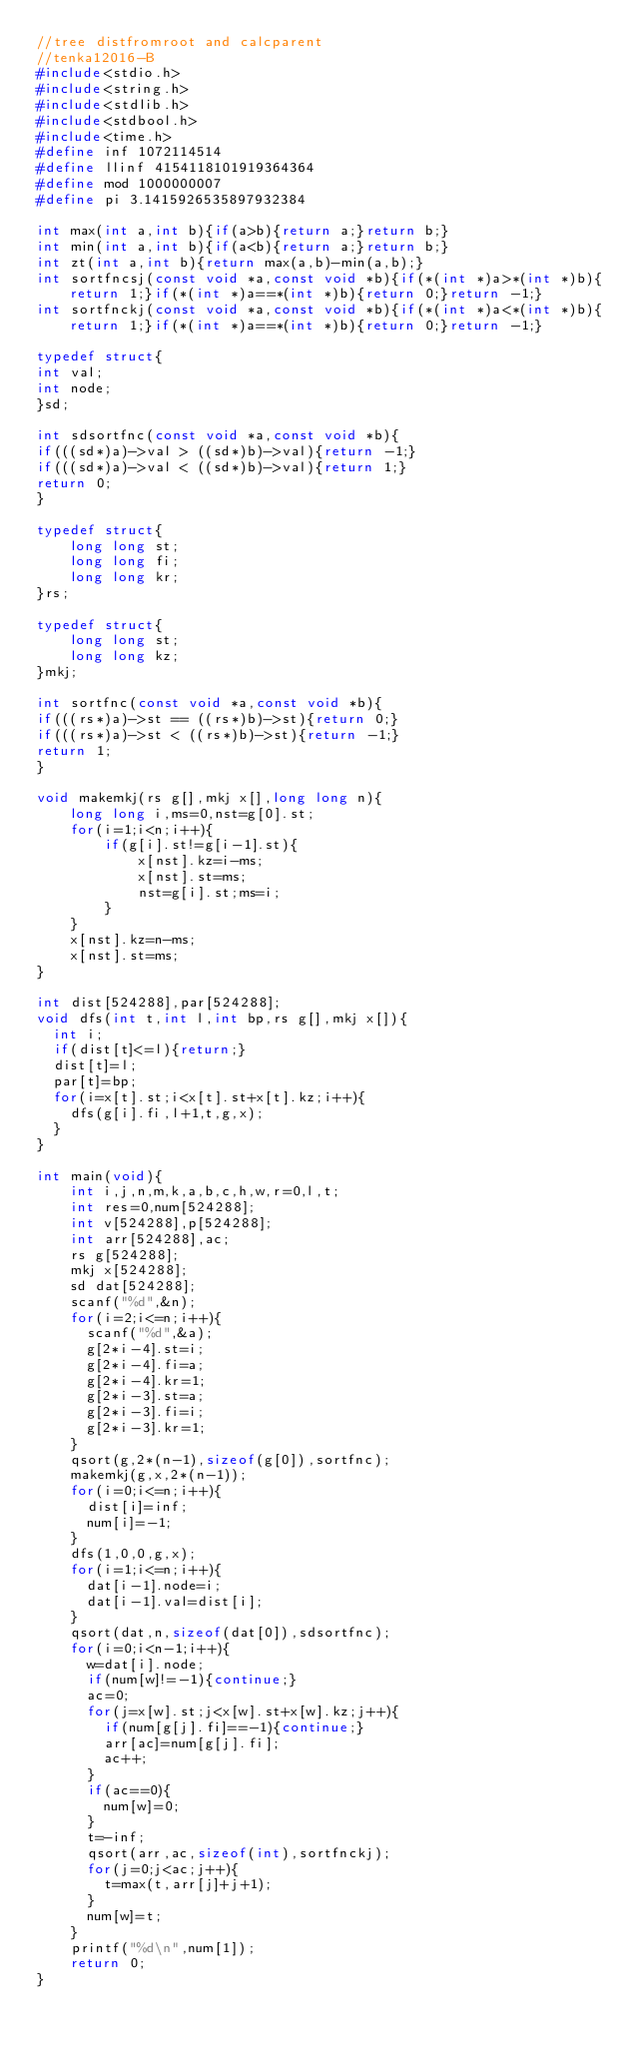<code> <loc_0><loc_0><loc_500><loc_500><_C_>//tree distfromroot and calcparent
//tenka12016-B
#include<stdio.h>
#include<string.h>
#include<stdlib.h>
#include<stdbool.h>
#include<time.h>
#define inf 1072114514
#define llinf 4154118101919364364
#define mod 1000000007
#define pi 3.1415926535897932384

int max(int a,int b){if(a>b){return a;}return b;}
int min(int a,int b){if(a<b){return a;}return b;}
int zt(int a,int b){return max(a,b)-min(a,b);}
int sortfncsj(const void *a,const void *b){if(*(int *)a>*(int *)b){return 1;}if(*(int *)a==*(int *)b){return 0;}return -1;}
int sortfnckj(const void *a,const void *b){if(*(int *)a<*(int *)b){return 1;}if(*(int *)a==*(int *)b){return 0;}return -1;}

typedef struct{
int val;
int node;
}sd;

int sdsortfnc(const void *a,const void *b){
if(((sd*)a)->val > ((sd*)b)->val){return -1;}
if(((sd*)a)->val < ((sd*)b)->val){return 1;}
return 0;
}

typedef struct{
    long long st;
    long long fi;
    long long kr;
}rs;

typedef struct{
    long long st;
    long long kz;
}mkj;

int sortfnc(const void *a,const void *b){
if(((rs*)a)->st == ((rs*)b)->st){return 0;}
if(((rs*)a)->st < ((rs*)b)->st){return -1;}
return 1;
}

void makemkj(rs g[],mkj x[],long long n){
    long long i,ms=0,nst=g[0].st;
    for(i=1;i<n;i++){
        if(g[i].st!=g[i-1].st){
            x[nst].kz=i-ms;
            x[nst].st=ms;
            nst=g[i].st;ms=i;
        }
    }
    x[nst].kz=n-ms;
    x[nst].st=ms;
}

int dist[524288],par[524288];
void dfs(int t,int l,int bp,rs g[],mkj x[]){
  int i;
  if(dist[t]<=l){return;}
  dist[t]=l;
  par[t]=bp;
  for(i=x[t].st;i<x[t].st+x[t].kz;i++){
    dfs(g[i].fi,l+1,t,g,x);
  }
}

int main(void){
    int i,j,n,m,k,a,b,c,h,w,r=0,l,t;
    int res=0,num[524288];
    int v[524288],p[524288];
    int arr[524288],ac;
    rs g[524288];
    mkj x[524288];
    sd dat[524288];
    scanf("%d",&n);
    for(i=2;i<=n;i++){
      scanf("%d",&a);
      g[2*i-4].st=i;
      g[2*i-4].fi=a;
      g[2*i-4].kr=1;
      g[2*i-3].st=a;
      g[2*i-3].fi=i;
      g[2*i-3].kr=1;
    }
    qsort(g,2*(n-1),sizeof(g[0]),sortfnc);
    makemkj(g,x,2*(n-1));
    for(i=0;i<=n;i++){
      dist[i]=inf;
      num[i]=-1;
    }
    dfs(1,0,0,g,x);
    for(i=1;i<=n;i++){
      dat[i-1].node=i;
      dat[i-1].val=dist[i];
    }
    qsort(dat,n,sizeof(dat[0]),sdsortfnc);
    for(i=0;i<n-1;i++){
      w=dat[i].node;
      if(num[w]!=-1){continue;}
      ac=0;
      for(j=x[w].st;j<x[w].st+x[w].kz;j++){
        if(num[g[j].fi]==-1){continue;}
        arr[ac]=num[g[j].fi];
        ac++;
      }
      if(ac==0){
        num[w]=0;
      }
      t=-inf;
      qsort(arr,ac,sizeof(int),sortfnckj);
      for(j=0;j<ac;j++){
        t=max(t,arr[j]+j+1);
      }
      num[w]=t;
    }
    printf("%d\n",num[1]);
    return 0;
}
</code> 